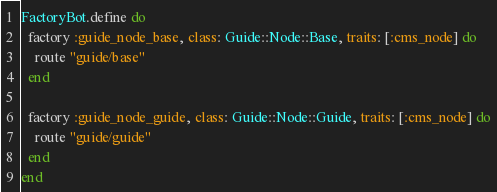<code> <loc_0><loc_0><loc_500><loc_500><_Ruby_>FactoryBot.define do
  factory :guide_node_base, class: Guide::Node::Base, traits: [:cms_node] do
    route "guide/base"
  end

  factory :guide_node_guide, class: Guide::Node::Guide, traits: [:cms_node] do
    route "guide/guide"
  end
end
</code> 